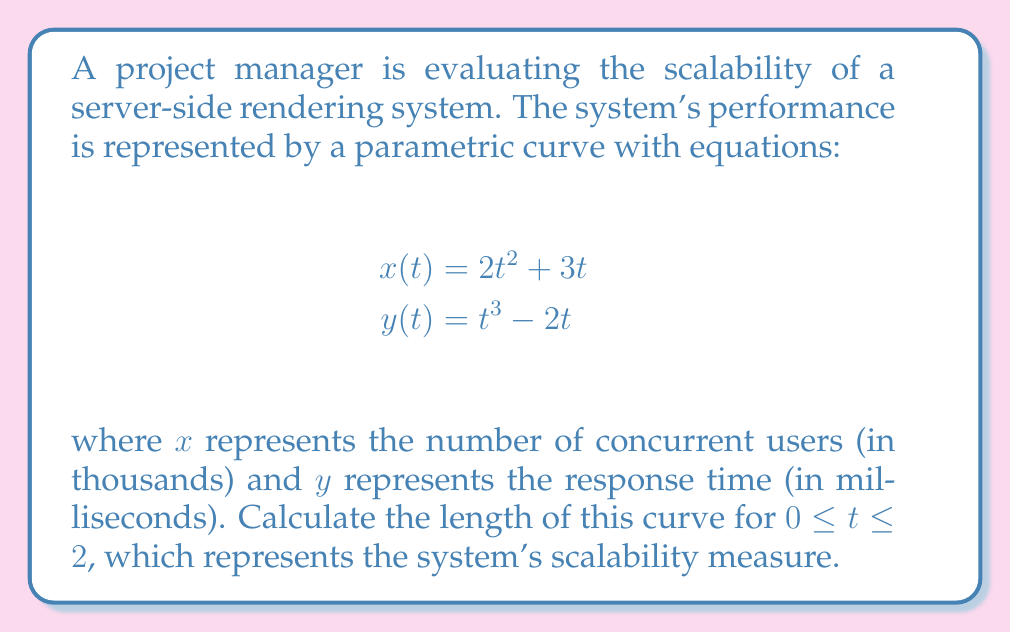Give your solution to this math problem. To find the length of a parametric curve, we use the arc length formula:

$$L = \int_a^b \sqrt{\left(\frac{dx}{dt}\right)^2 + \left(\frac{dy}{dt}\right)^2} dt$$

Step 1: Find $\frac{dx}{dt}$ and $\frac{dy}{dt}$
$$\frac{dx}{dt} = 4t + 3$$
$$\frac{dy}{dt} = 3t^2 - 2$$

Step 2: Substitute into the arc length formula
$$L = \int_0^2 \sqrt{(4t + 3)^2 + (3t^2 - 2)^2} dt$$

Step 3: Simplify the expression under the square root
$$L = \int_0^2 \sqrt{16t^2 + 24t + 9 + 9t^4 - 12t^2 + 4} dt$$
$$L = \int_0^2 \sqrt{9t^4 + 4t^2 + 24t + 13} dt$$

Step 4: This integral cannot be solved analytically, so we need to use numerical integration methods. Using a computer algebra system or numerical integration tool, we can evaluate this integral.

The result of this numerical integration is approximately 17.8934.
Answer: The length of the parametric curve representing the scalability of the server-side rendering system for $0 \leq t \leq 2$ is approximately 17.8934 units. 